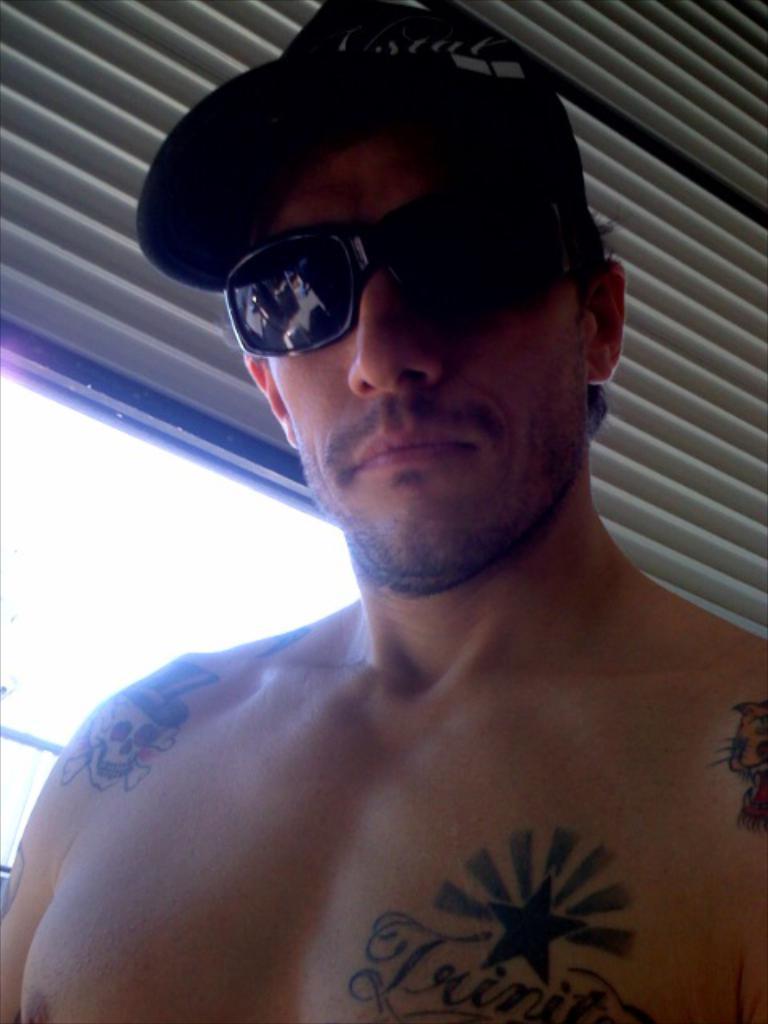How would you summarize this image in a sentence or two? This person wore goggles and cap. On this person's body there are tattoos. Here we can see window.  